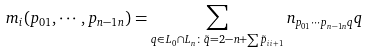Convert formula to latex. <formula><loc_0><loc_0><loc_500><loc_500>m _ { i } ( p _ { 0 1 } , \cdots , p _ { n - 1 n } ) = \sum _ { q \in L _ { 0 } \cap L _ { n } \colon \tilde { q } = 2 - n + \sum \tilde { p } _ { i i + 1 } } n _ { p _ { 0 1 } \cdots p _ { n - 1 n } q } q</formula> 